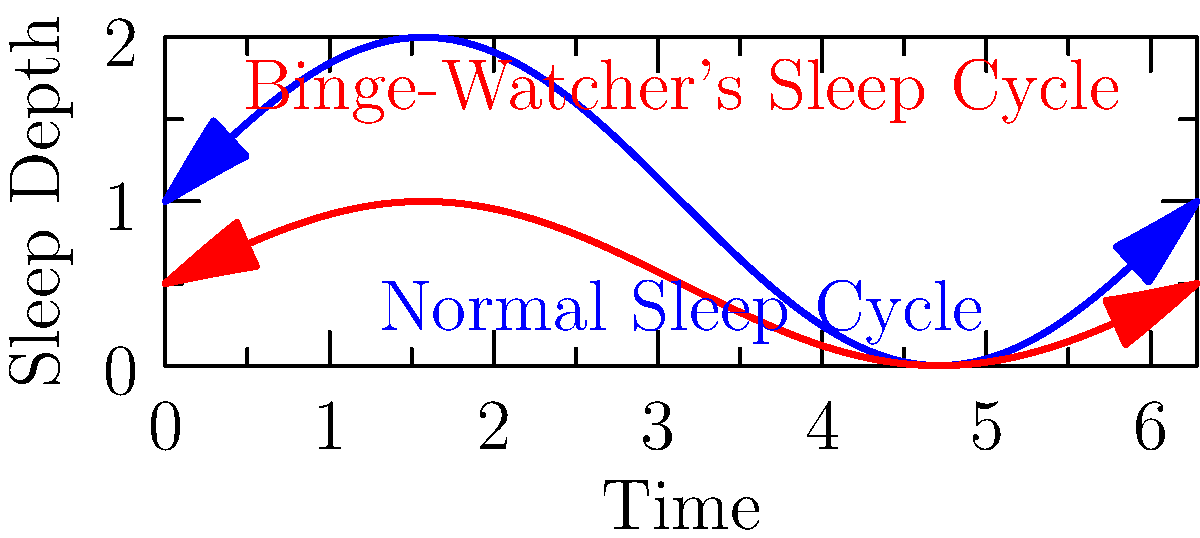The graph shows two sleep cycle patterns over a night. The blue line represents a normal sleep cycle, while the red line represents the sleep cycle of a person who has been binge-watching TV shows. Based on this information, what is the primary effect of binge-watching on the sleep cycle, and how might this impact overall sleep quality for a TV enthusiast? To answer this question, let's analyze the graph step-by-step:

1. Normal Sleep Cycle (Blue Line):
   - Shows deeper troughs, indicating deeper sleep stages
   - Has a consistent pattern with regular intervals
   - Completes approximately 4-5 full cycles over the night

2. Binge-Watcher's Sleep Cycle (Red Line):
   - Has shallower troughs, suggesting less deep sleep
   - Shows a more irregular pattern
   - Appears to have fewer complete cycles

3. Comparing the two patterns:
   - The binge-watcher's cycle doesn't reach the same depth of sleep
   - The intervals between cycles are less regular for the binge-watcher
   - The binge-watcher seems to experience fewer complete sleep cycles

4. Impact on sleep quality:
   - Less deep sleep: Deep sleep is crucial for physical restoration and memory consolidation
   - Irregular cycles: May lead to more frequent awakenings or lighter sleep overall
   - Fewer complete cycles: Could result in feeling less rested upon waking

5. Relevance to a TV enthusiast:
   - Binge-watching often leads to later bedtimes and exposure to blue light before sleep
   - The excitement from watching shows may increase arousal, making it harder to fall into deep sleep
   - The desire to watch "just one more episode" can lead to sleep deprivation

The primary effect of binge-watching on the sleep cycle is a reduction in sleep depth and cycle regularity. This can lead to poorer overall sleep quality, potentially causing daytime fatigue, reduced cognitive function, and long-term health issues if the pattern persists.
Answer: Reduced sleep depth and cycle regularity, leading to poorer overall sleep quality. 